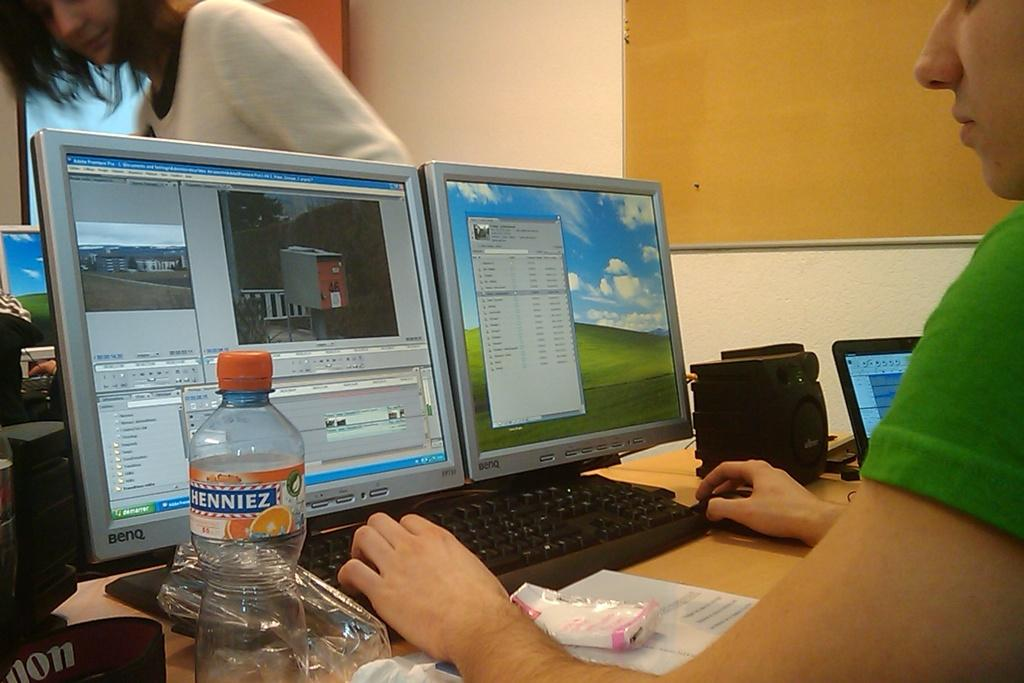<image>
Give a short and clear explanation of the subsequent image. A clear bottle with an orange bottle cap labeled Henniez 